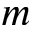Convert formula to latex. <formula><loc_0><loc_0><loc_500><loc_500>m</formula> 